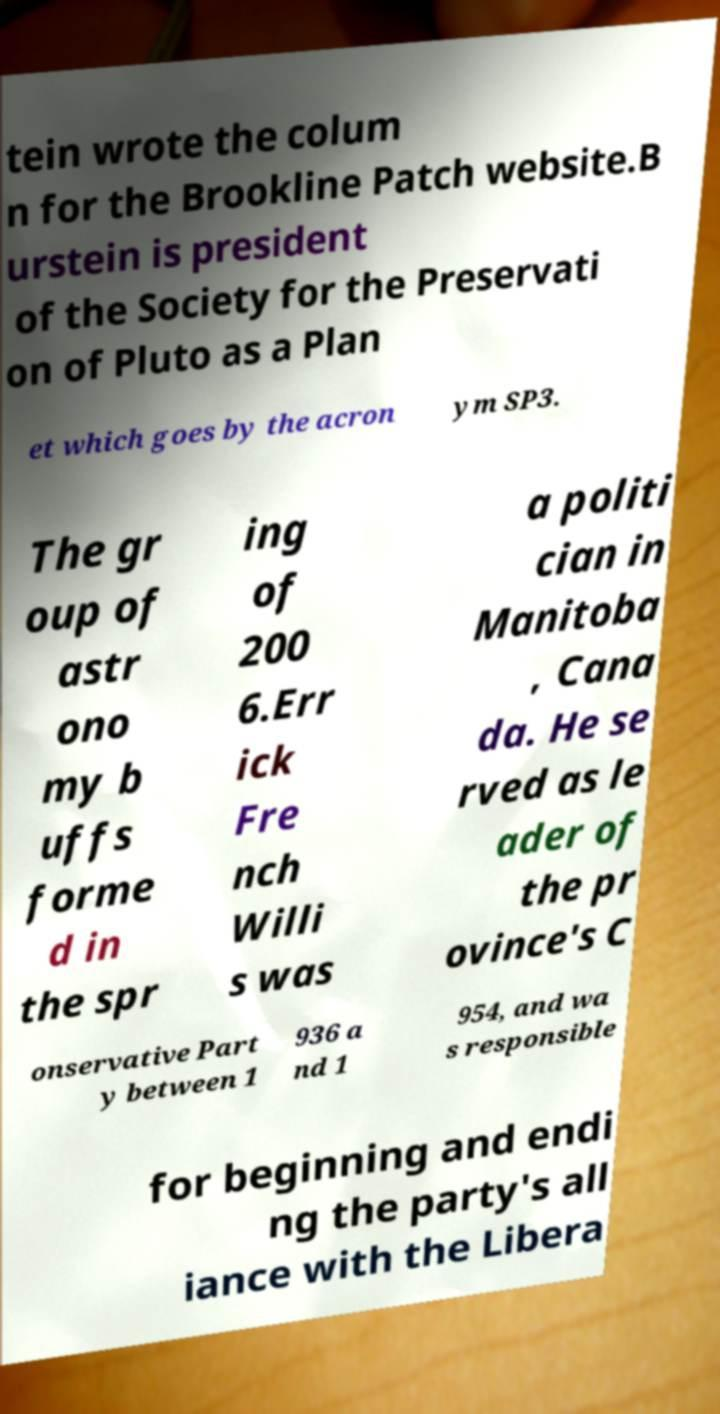Could you assist in decoding the text presented in this image and type it out clearly? tein wrote the colum n for the Brookline Patch website.B urstein is president of the Society for the Preservati on of Pluto as a Plan et which goes by the acron ym SP3. The gr oup of astr ono my b uffs forme d in the spr ing of 200 6.Err ick Fre nch Willi s was a politi cian in Manitoba , Cana da. He se rved as le ader of the pr ovince's C onservative Part y between 1 936 a nd 1 954, and wa s responsible for beginning and endi ng the party's all iance with the Libera 